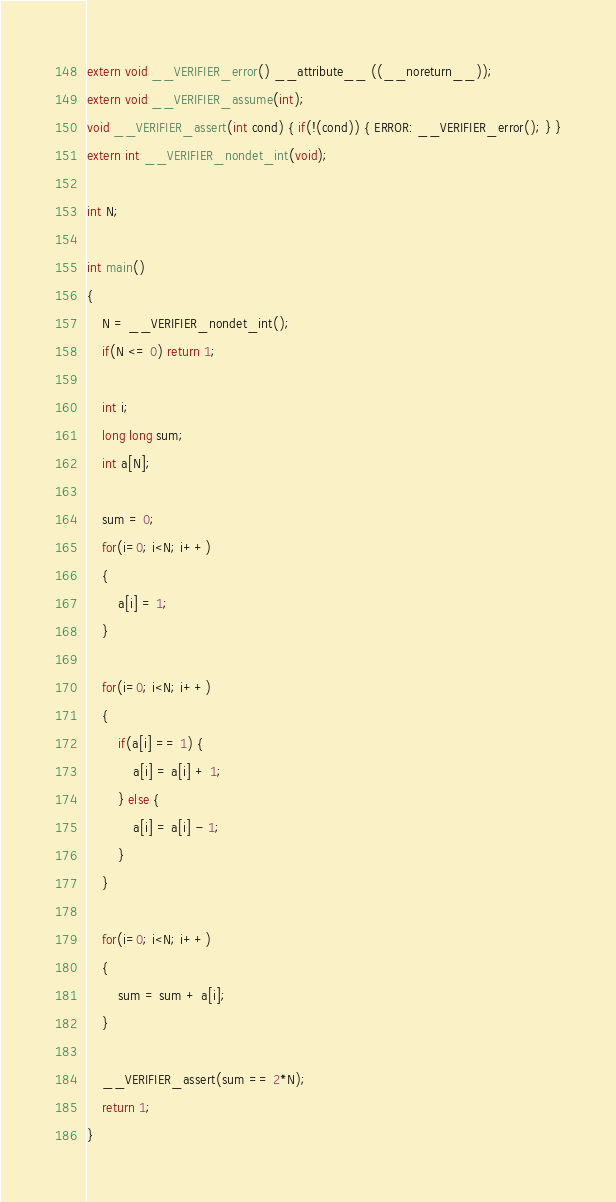Convert code to text. <code><loc_0><loc_0><loc_500><loc_500><_C_>extern void __VERIFIER_error() __attribute__ ((__noreturn__));
extern void __VERIFIER_assume(int);
void __VERIFIER_assert(int cond) { if(!(cond)) { ERROR: __VERIFIER_error(); } }
extern int __VERIFIER_nondet_int(void);

int N;

int main()
{
	N = __VERIFIER_nondet_int();
	if(N <= 0) return 1;

	int i;
	long long sum;
	int a[N];

	sum = 0;
	for(i=0; i<N; i++)
	{
		a[i] = 1;
	}

	for(i=0; i<N; i++)
	{
		if(a[i] == 1) {
			a[i] = a[i] + 1;
		} else {
			a[i] = a[i] - 1;
		}
	}

	for(i=0; i<N; i++)
	{
		sum = sum + a[i];
	}

	__VERIFIER_assert(sum == 2*N);
	return 1;
}
</code> 